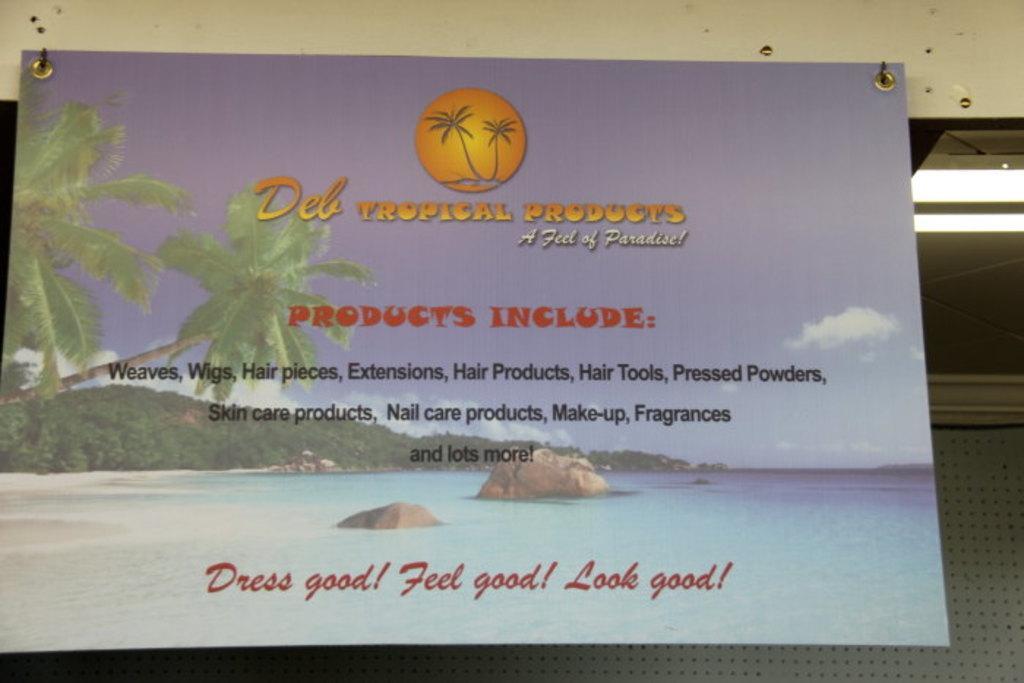Can you describe this image briefly? In this image we can see the banner with text and images attached to the wall. And we can see the lights on the right side. In the background, we can see a metal object. 